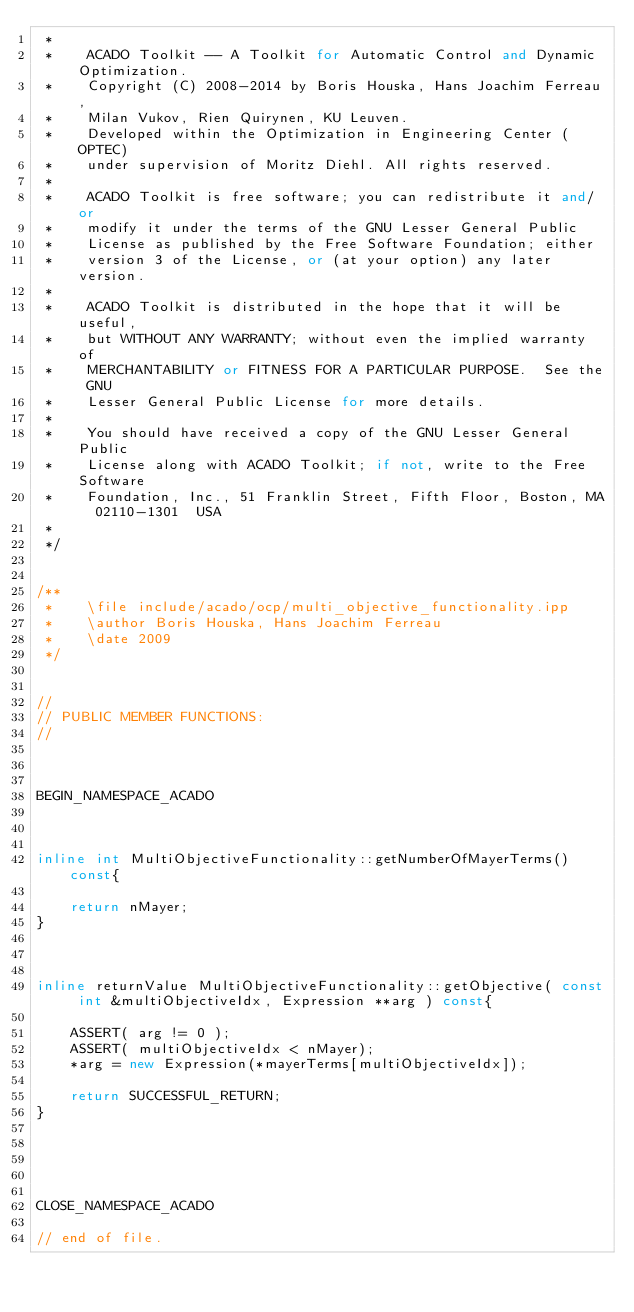<code> <loc_0><loc_0><loc_500><loc_500><_C++_> *
 *    ACADO Toolkit -- A Toolkit for Automatic Control and Dynamic Optimization.
 *    Copyright (C) 2008-2014 by Boris Houska, Hans Joachim Ferreau,
 *    Milan Vukov, Rien Quirynen, KU Leuven.
 *    Developed within the Optimization in Engineering Center (OPTEC)
 *    under supervision of Moritz Diehl. All rights reserved.
 *
 *    ACADO Toolkit is free software; you can redistribute it and/or
 *    modify it under the terms of the GNU Lesser General Public
 *    License as published by the Free Software Foundation; either
 *    version 3 of the License, or (at your option) any later version.
 *
 *    ACADO Toolkit is distributed in the hope that it will be useful,
 *    but WITHOUT ANY WARRANTY; without even the implied warranty of
 *    MERCHANTABILITY or FITNESS FOR A PARTICULAR PURPOSE.  See the GNU
 *    Lesser General Public License for more details.
 *
 *    You should have received a copy of the GNU Lesser General Public
 *    License along with ACADO Toolkit; if not, write to the Free Software
 *    Foundation, Inc., 51 Franklin Street, Fifth Floor, Boston, MA  02110-1301  USA
 *
 */


/**
 *    \file include/acado/ocp/multi_objective_functionality.ipp
 *    \author Boris Houska, Hans Joachim Ferreau
 *    \date 2009
 */


//
// PUBLIC MEMBER FUNCTIONS:
//



BEGIN_NAMESPACE_ACADO



inline int MultiObjectiveFunctionality::getNumberOfMayerTerms() const{

    return nMayer;
}



inline returnValue MultiObjectiveFunctionality::getObjective( const int &multiObjectiveIdx, Expression **arg ) const{

    ASSERT( arg != 0 );
    ASSERT( multiObjectiveIdx < nMayer);
    *arg = new Expression(*mayerTerms[multiObjectiveIdx]);

    return SUCCESSFUL_RETURN;
}





CLOSE_NAMESPACE_ACADO

// end of file.
</code> 